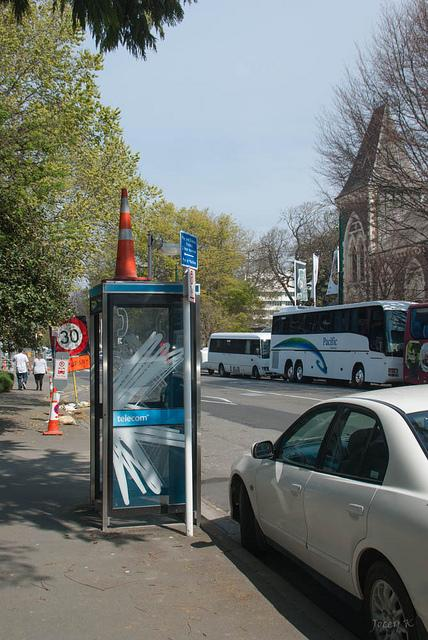Originally what was the glass booth designed for?

Choices:
A) police monitoring
B) phone calls
C) sentry guard
D) toll taking phone calls 